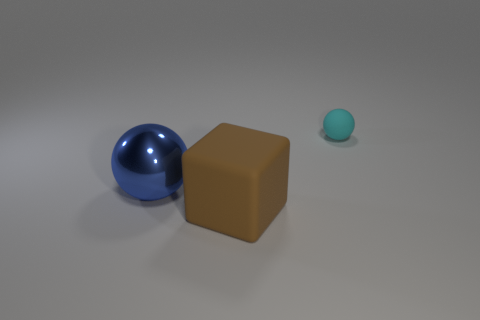Can you describe the surface the objects are resting on? The objects are resting on a smooth, flat surface with a slight reflection, indicating it could be made of a polished material like laminated wood, smooth stone, or synthetic material. The consistent, neutral grey tone of the surface suggests it's been chosen to avoid distracting from the objects placed upon it, again reflective of a controlled, studio-like setting. 